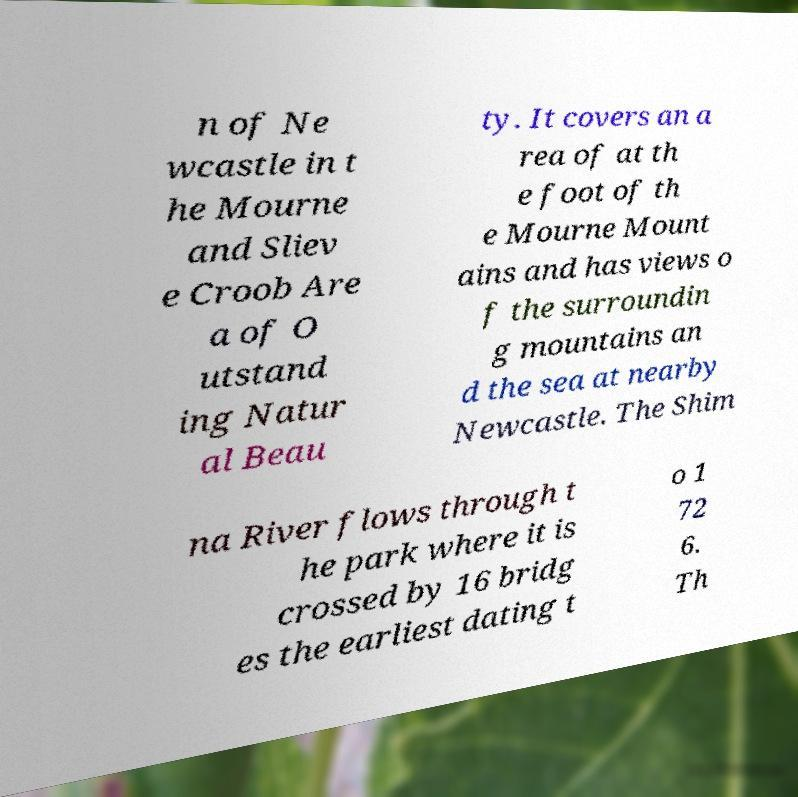Please identify and transcribe the text found in this image. n of Ne wcastle in t he Mourne and Sliev e Croob Are a of O utstand ing Natur al Beau ty. It covers an a rea of at th e foot of th e Mourne Mount ains and has views o f the surroundin g mountains an d the sea at nearby Newcastle. The Shim na River flows through t he park where it is crossed by 16 bridg es the earliest dating t o 1 72 6. Th 